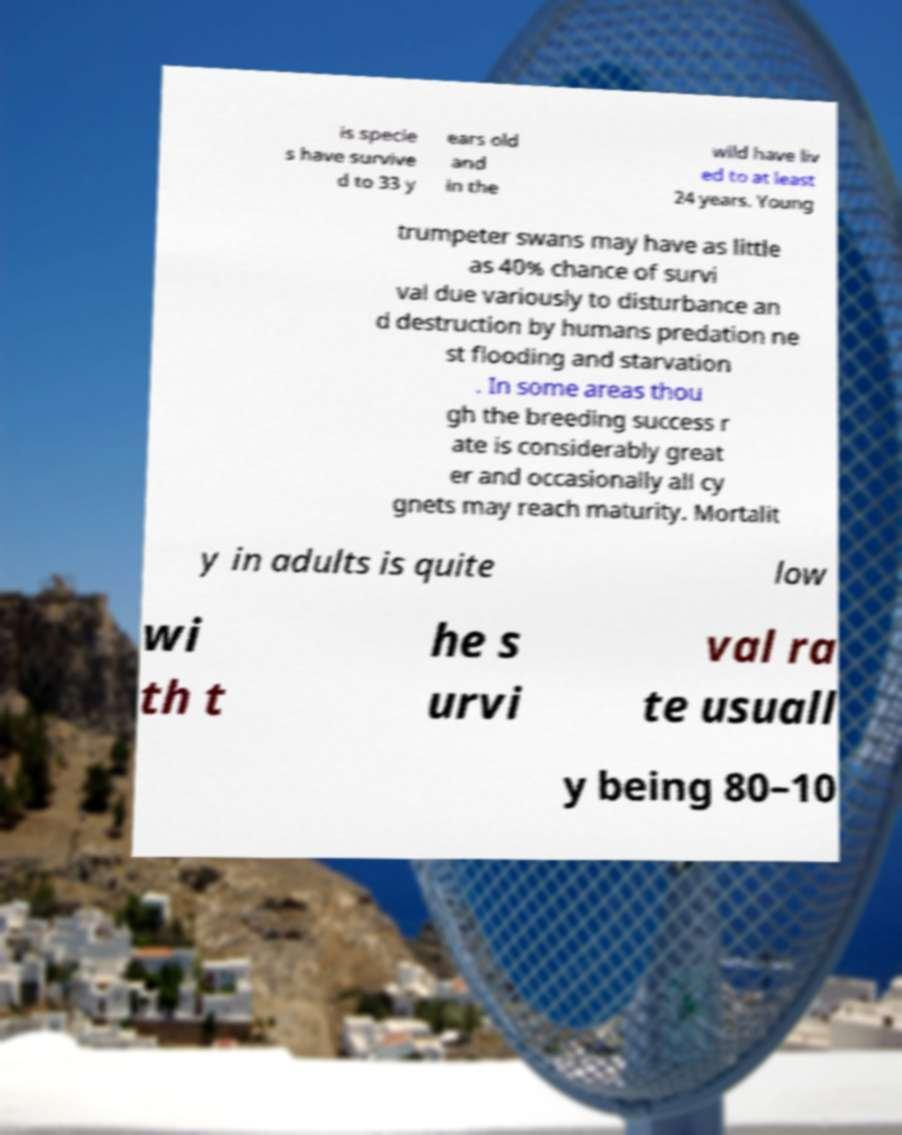Could you assist in decoding the text presented in this image and type it out clearly? is specie s have survive d to 33 y ears old and in the wild have liv ed to at least 24 years. Young trumpeter swans may have as little as 40% chance of survi val due variously to disturbance an d destruction by humans predation ne st flooding and starvation . In some areas thou gh the breeding success r ate is considerably great er and occasionally all cy gnets may reach maturity. Mortalit y in adults is quite low wi th t he s urvi val ra te usuall y being 80–10 